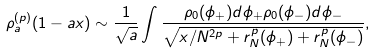<formula> <loc_0><loc_0><loc_500><loc_500>\rho _ { a } ^ { ( p ) } ( 1 - a x ) \sim \frac { 1 } { \sqrt { a } } \int \frac { \rho _ { 0 } ( \phi _ { + } ) d \phi _ { + } \rho _ { 0 } ( \phi _ { - } ) d \phi _ { - } } { \sqrt { x / N ^ { 2 p } + r _ { N } ^ { p } ( \phi _ { + } ) + r _ { N } ^ { p } ( \phi _ { - } ) } } ,</formula> 